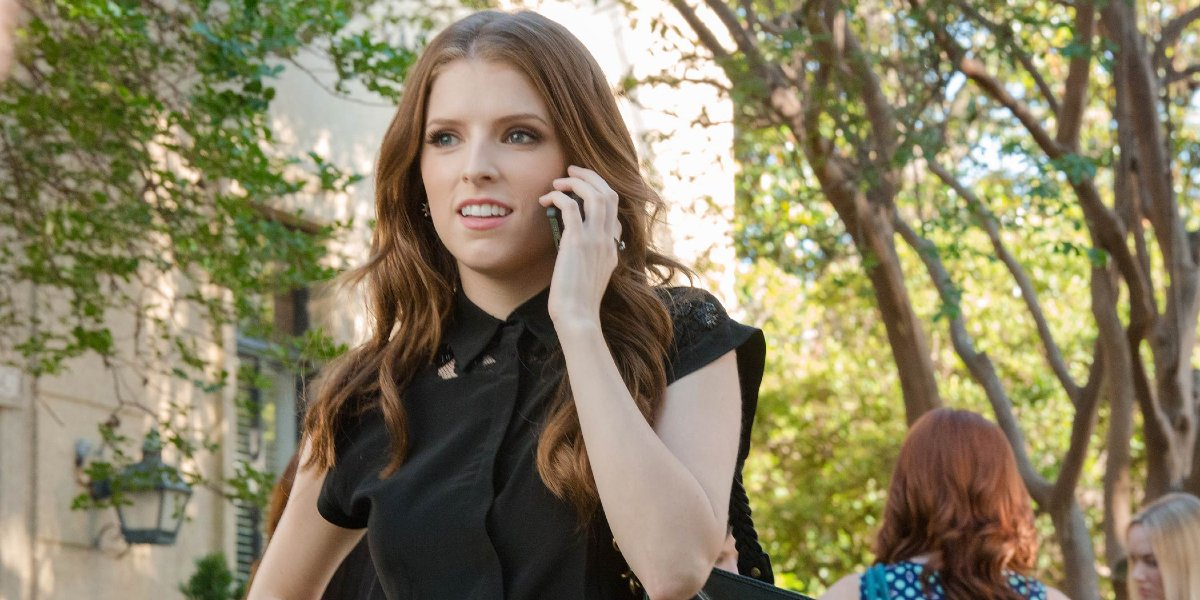What do you see happening in this image? In the image, there's a woman walking on a tree-lined street while talking on her cellphone. She is dressed in casual clothing and seems focused on the conversation, possibly dealing with a serious matter given her expression. The image captures a moment that appears to be from everyday life, set against a backdrop of green foliage and a calm urban environment. 